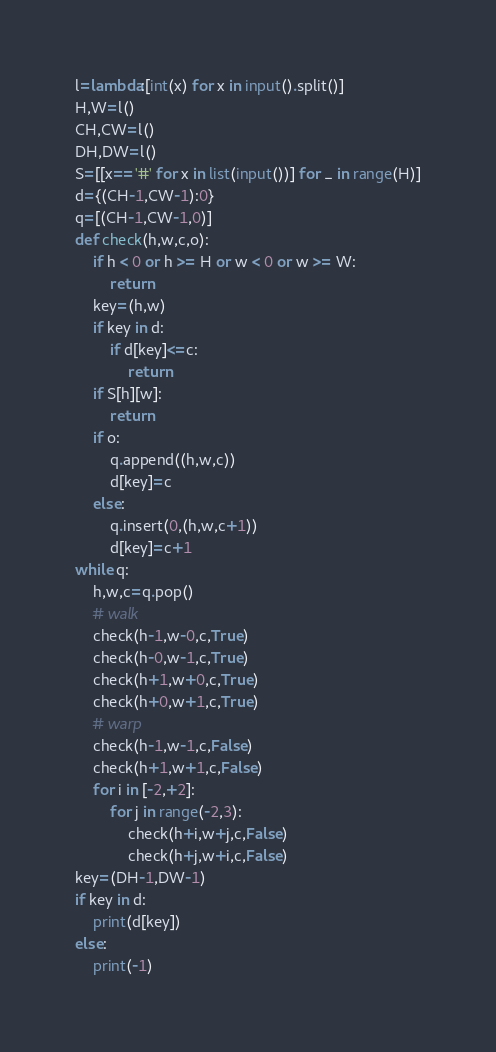Convert code to text. <code><loc_0><loc_0><loc_500><loc_500><_Python_>l=lambda:[int(x) for x in input().split()]
H,W=l()
CH,CW=l()
DH,DW=l()
S=[[x=='#' for x in list(input())] for _ in range(H)]
d={(CH-1,CW-1):0}
q=[(CH-1,CW-1,0)]
def check(h,w,c,o):
    if h < 0 or h >= H or w < 0 or w >= W:
        return
    key=(h,w)
    if key in d:
        if d[key]<=c:
            return
    if S[h][w]:
        return
    if o:
        q.append((h,w,c))
        d[key]=c
    else:
        q.insert(0,(h,w,c+1))
        d[key]=c+1
while q:
    h,w,c=q.pop()
    # walk
    check(h-1,w-0,c,True)
    check(h-0,w-1,c,True)
    check(h+1,w+0,c,True)
    check(h+0,w+1,c,True)
    # warp
    check(h-1,w-1,c,False)
    check(h+1,w+1,c,False)
    for i in [-2,+2]:
        for j in range(-2,3):
            check(h+i,w+j,c,False)
            check(h+j,w+i,c,False)
key=(DH-1,DW-1)
if key in d:
    print(d[key])
else:
    print(-1)</code> 